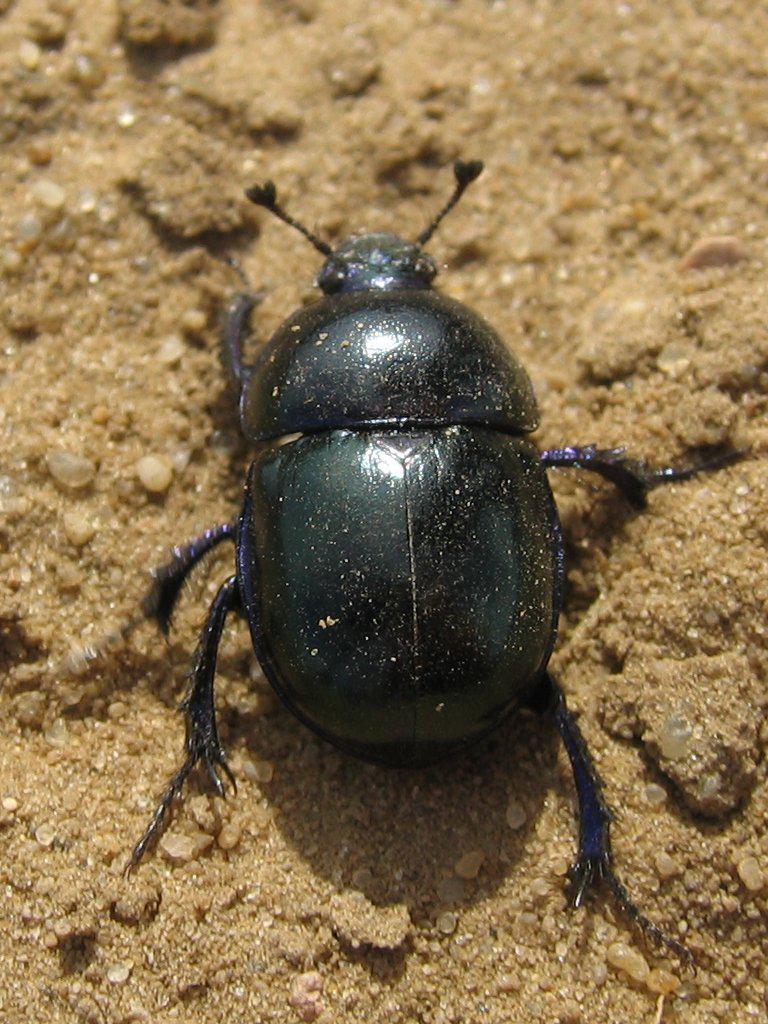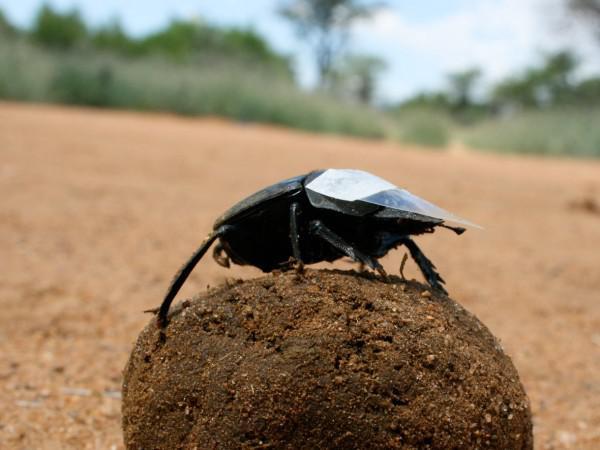The first image is the image on the left, the second image is the image on the right. Assess this claim about the two images: "Images show a total of two beetles and two dung balls.". Correct or not? Answer yes or no. No. 